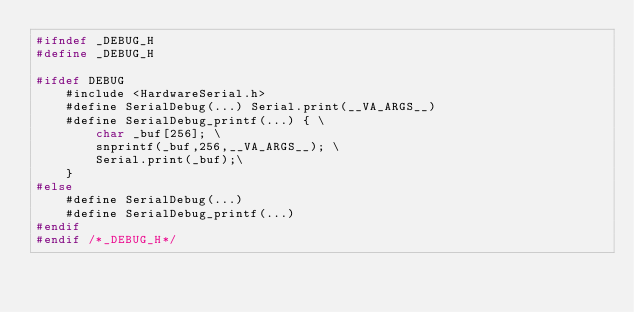Convert code to text. <code><loc_0><loc_0><loc_500><loc_500><_C_>#ifndef _DEBUG_H
#define _DEBUG_H

#ifdef DEBUG
    #include <HardwareSerial.h>
    #define SerialDebug(...) Serial.print(__VA_ARGS__)
    #define SerialDebug_printf(...) { \
        char _buf[256]; \
        snprintf(_buf,256,__VA_ARGS__); \
        Serial.print(_buf);\
    }
#else
    #define SerialDebug(...)
    #define SerialDebug_printf(...)
#endif
#endif /*_DEBUG_H*/</code> 